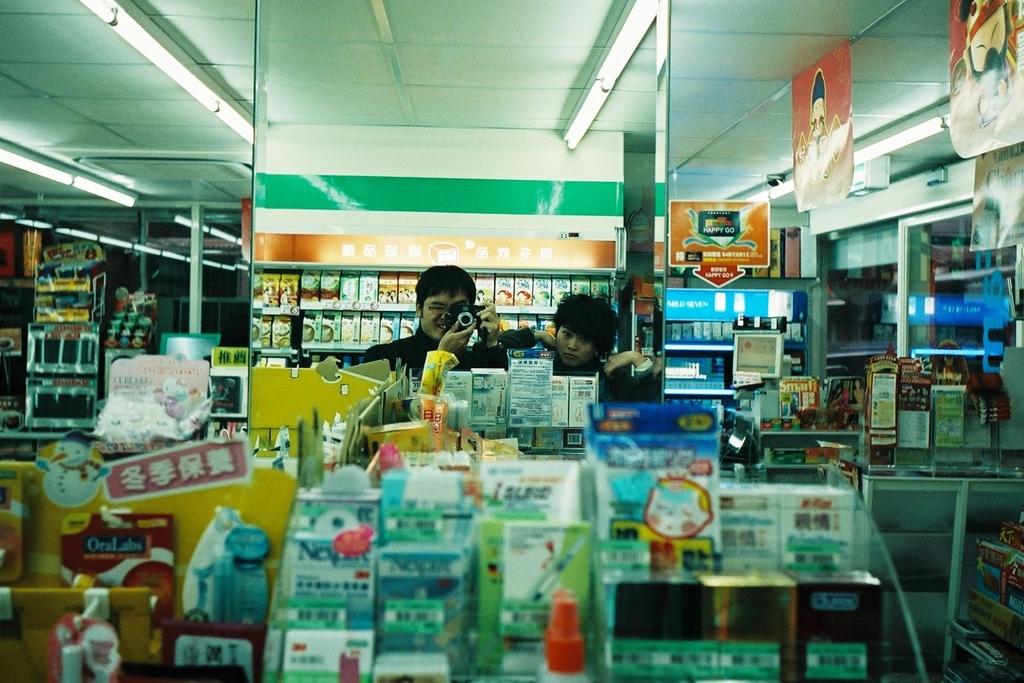How many people are in the image? There are two people in the image. Can you describe one of the people in the image? One of the people is a man. What is the man holding in the image? The man is holding a camera with his hands. What is the man's facial expression in the image? The man is smiling. What type of objects can be seen in the image? There are boxes, packets, and objects in racks visible in the image. What can be seen in the background of the image? There are lights visible in the background of the image. What type of badge is the man wearing in the image? There is no badge visible on the man in the image. What advice is the man giving to the other person in the image? The image does not show the man giving any advice to the other person. 